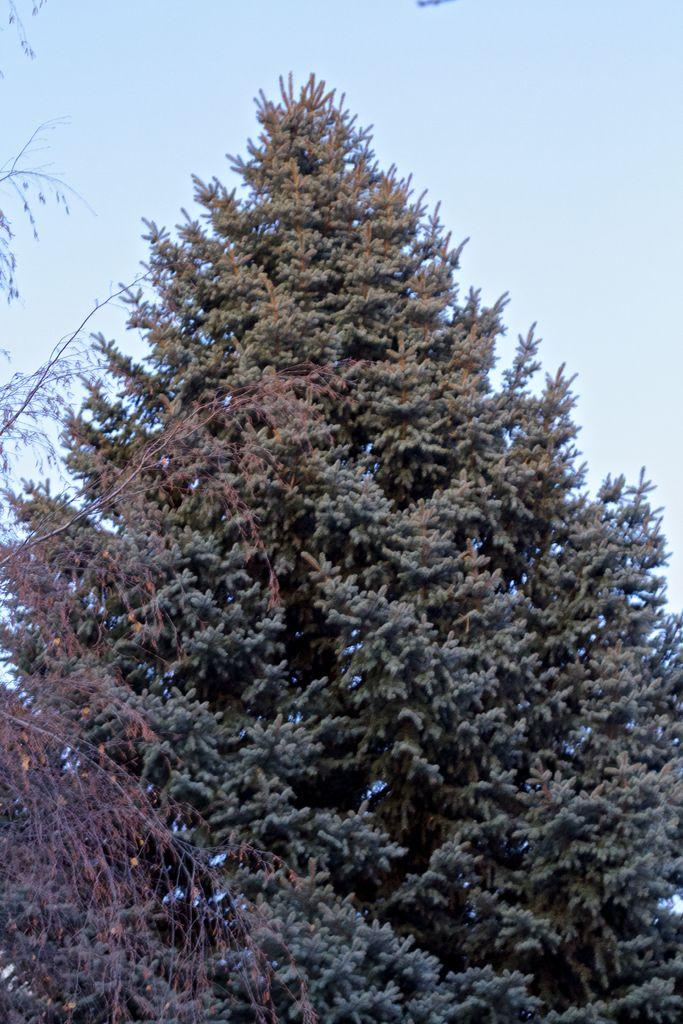What type of vegetation can be seen in the image? There are trees in the image. What part of the natural environment is visible in the image? The sky is visible in the background of the image. What is the texture of the writer's request in the image? There is no writer or request present in the image. 